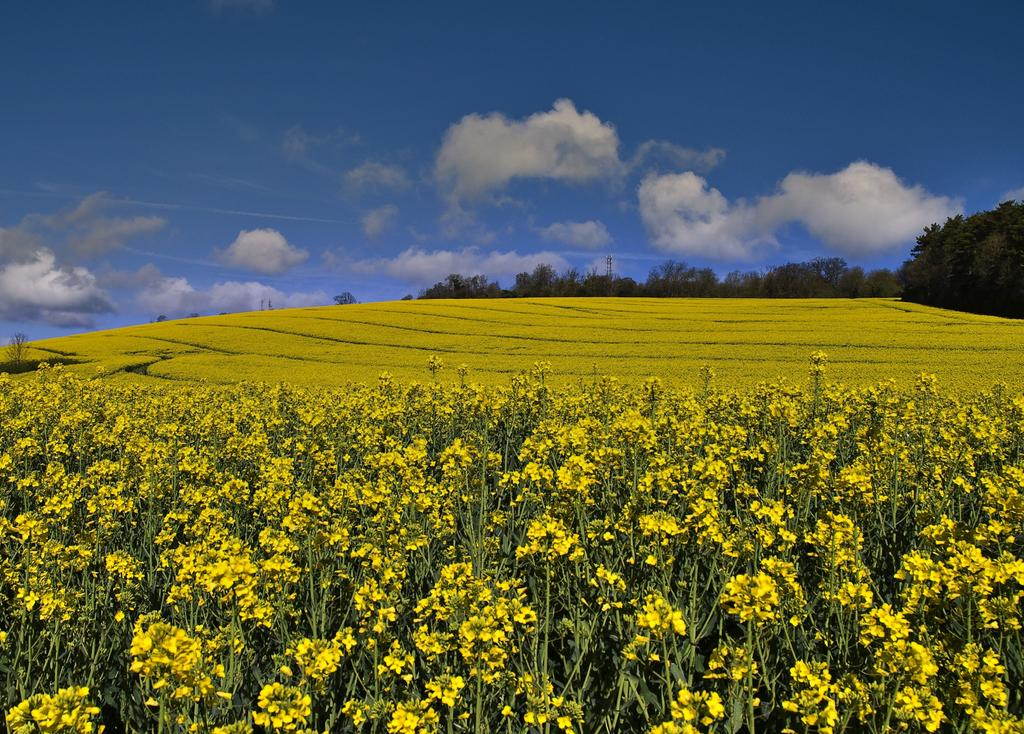What types of vegetation can be seen in the front of the image? There are plants and flowers in the front of the image. What can be seen in the background of the image? There are trees in the background of the image. What is visible at the top of the image? The sky is visible at the top of the image. What type of button can be seen in the image? There is no button present in the image. How can the plants and flowers in the image be increased? The question of increasing the plants and flowers in the image is not relevant, as the image is a static representation and does not involve any actions or changes. 